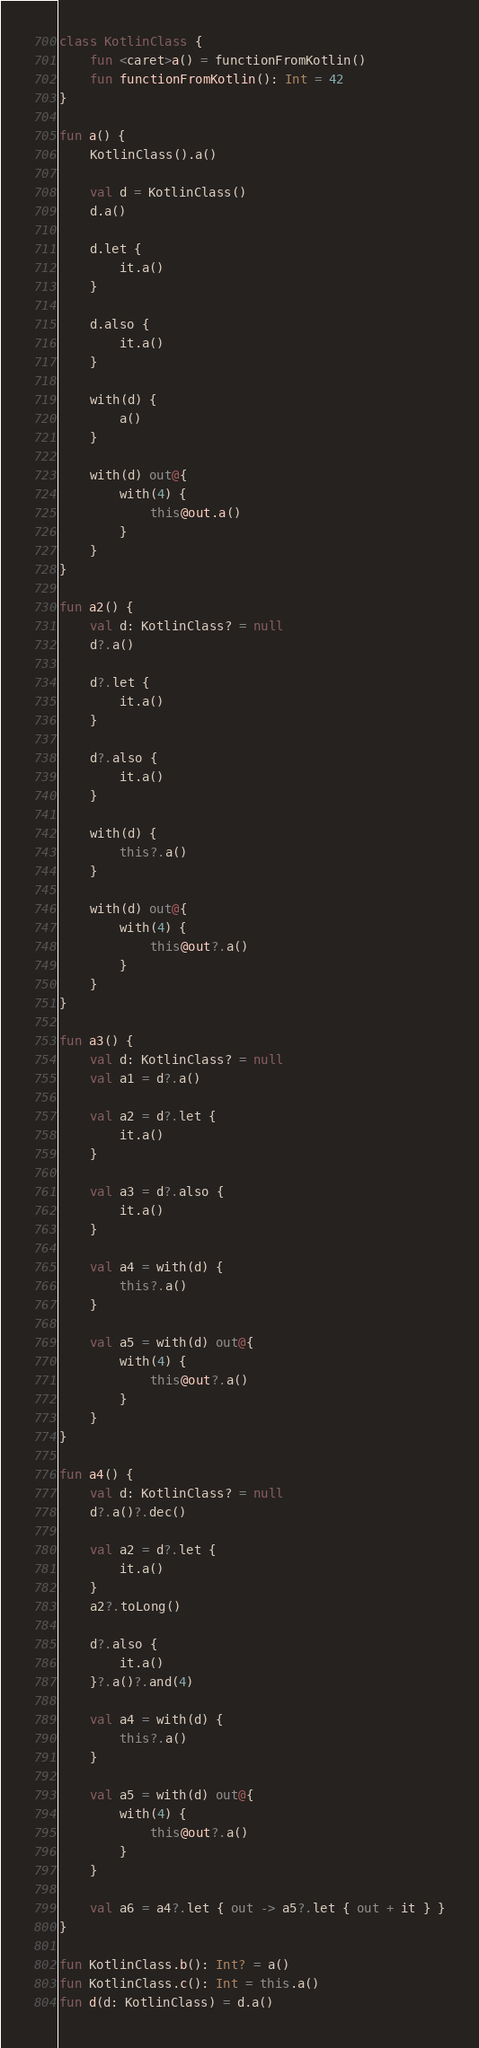<code> <loc_0><loc_0><loc_500><loc_500><_Kotlin_>class KotlinClass {
    fun <caret>a() = functionFromKotlin()
    fun functionFromKotlin(): Int = 42
}

fun a() {
    KotlinClass().a()

    val d = KotlinClass()
    d.a()

    d.let {
        it.a()
    }

    d.also {
        it.a()
    }

    with(d) {
        a()
    }

    with(d) out@{
        with(4) {
            this@out.a()
        }
    }
}

fun a2() {
    val d: KotlinClass? = null
    d?.a()

    d?.let {
        it.a()
    }

    d?.also {
        it.a()
    }

    with(d) {
        this?.a()
    }

    with(d) out@{
        with(4) {
            this@out?.a()
        }
    }
}

fun a3() {
    val d: KotlinClass? = null
    val a1 = d?.a()

    val a2 = d?.let {
        it.a()
    }

    val a3 = d?.also {
        it.a()
    }

    val a4 = with(d) {
        this?.a()
    }

    val a5 = with(d) out@{
        with(4) {
            this@out?.a()
        }
    }
}

fun a4() {
    val d: KotlinClass? = null
    d?.a()?.dec()

    val a2 = d?.let {
        it.a()
    }
    a2?.toLong()

    d?.also {
        it.a()
    }?.a()?.and(4)

    val a4 = with(d) {
        this?.a()
    }

    val a5 = with(d) out@{
        with(4) {
            this@out?.a()
        }
    }

    val a6 = a4?.let { out -> a5?.let { out + it } }
}

fun KotlinClass.b(): Int? = a()
fun KotlinClass.c(): Int = this.a()
fun d(d: KotlinClass) = d.a()
</code> 